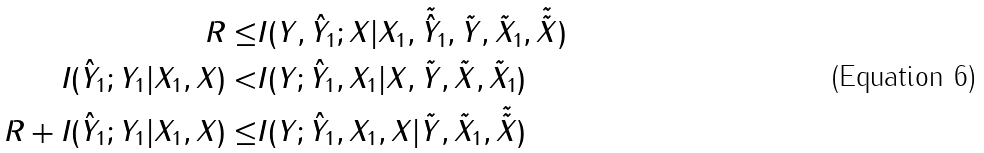<formula> <loc_0><loc_0><loc_500><loc_500>R \leq & I ( Y , \hat { Y } _ { 1 } ; X | X _ { 1 } , \tilde { \hat { Y } } _ { 1 } , \tilde { Y } , \tilde { X } _ { 1 } , \tilde { \tilde { X } } ) \\ I ( \hat { Y } _ { 1 } ; Y _ { 1 } | X _ { 1 } , X ) < & I ( Y ; \hat { Y } _ { 1 } , X _ { 1 } | X , \tilde { Y } , \tilde { X } , \tilde { X } _ { 1 } ) \\ R + I ( \hat { Y } _ { 1 } ; Y _ { 1 } | X _ { 1 } , X ) \leq & I ( Y ; \hat { Y } _ { 1 } , X _ { 1 } , X | \tilde { Y } , \tilde { X } _ { 1 } , \tilde { \tilde { X } } )</formula> 